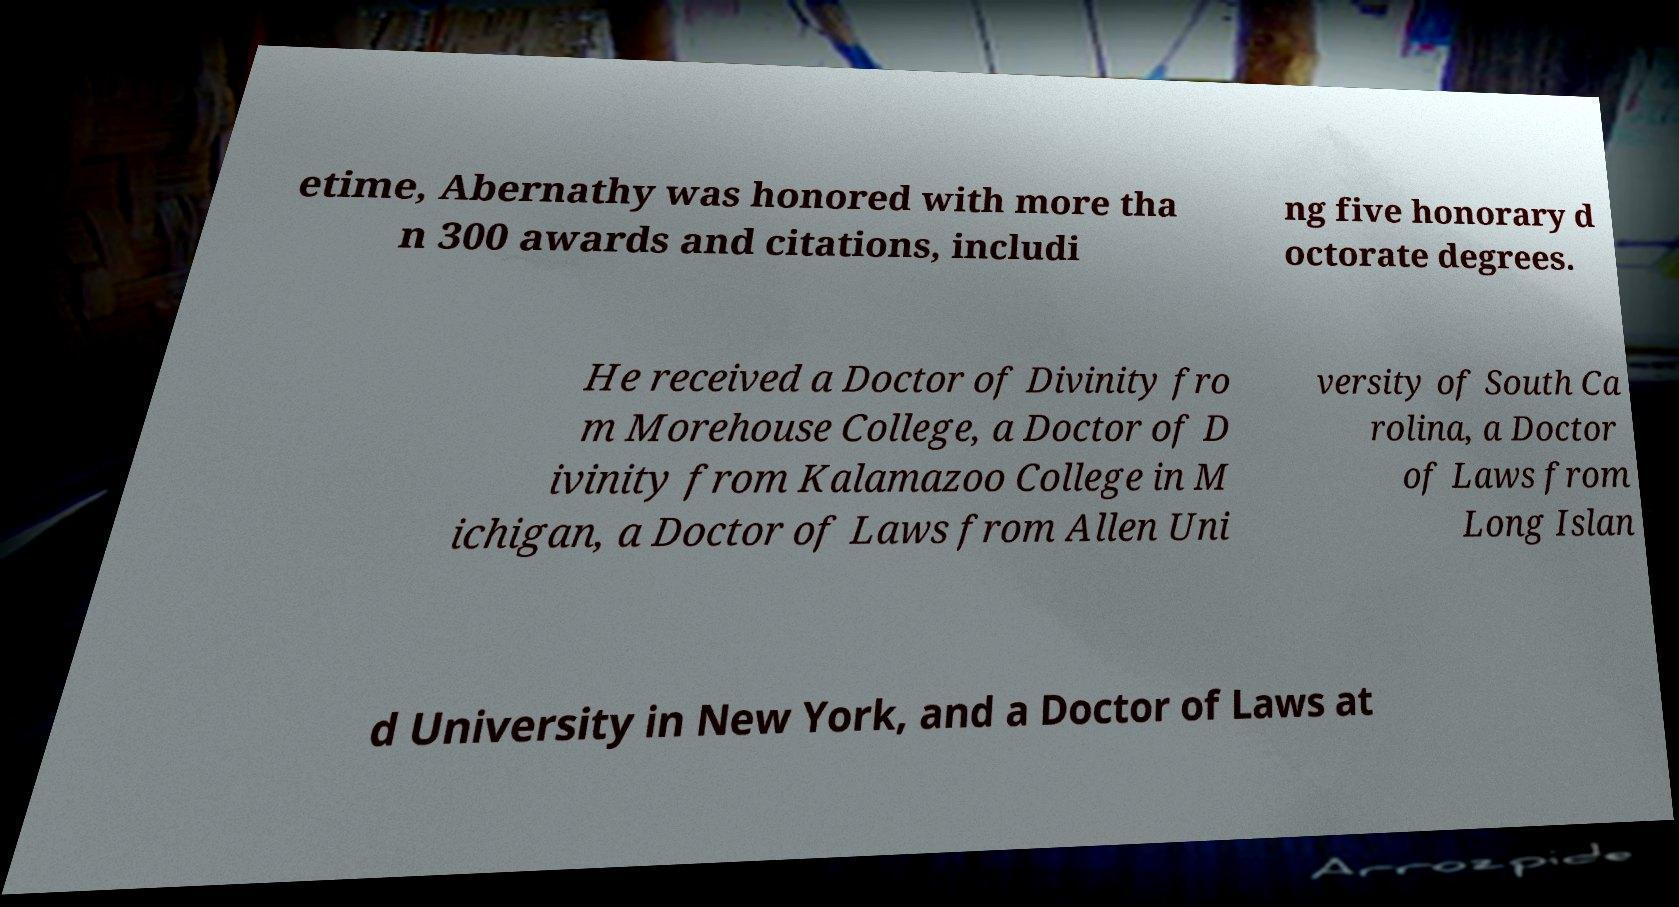What messages or text are displayed in this image? I need them in a readable, typed format. etime, Abernathy was honored with more tha n 300 awards and citations, includi ng five honorary d octorate degrees. He received a Doctor of Divinity fro m Morehouse College, a Doctor of D ivinity from Kalamazoo College in M ichigan, a Doctor of Laws from Allen Uni versity of South Ca rolina, a Doctor of Laws from Long Islan d University in New York, and a Doctor of Laws at 